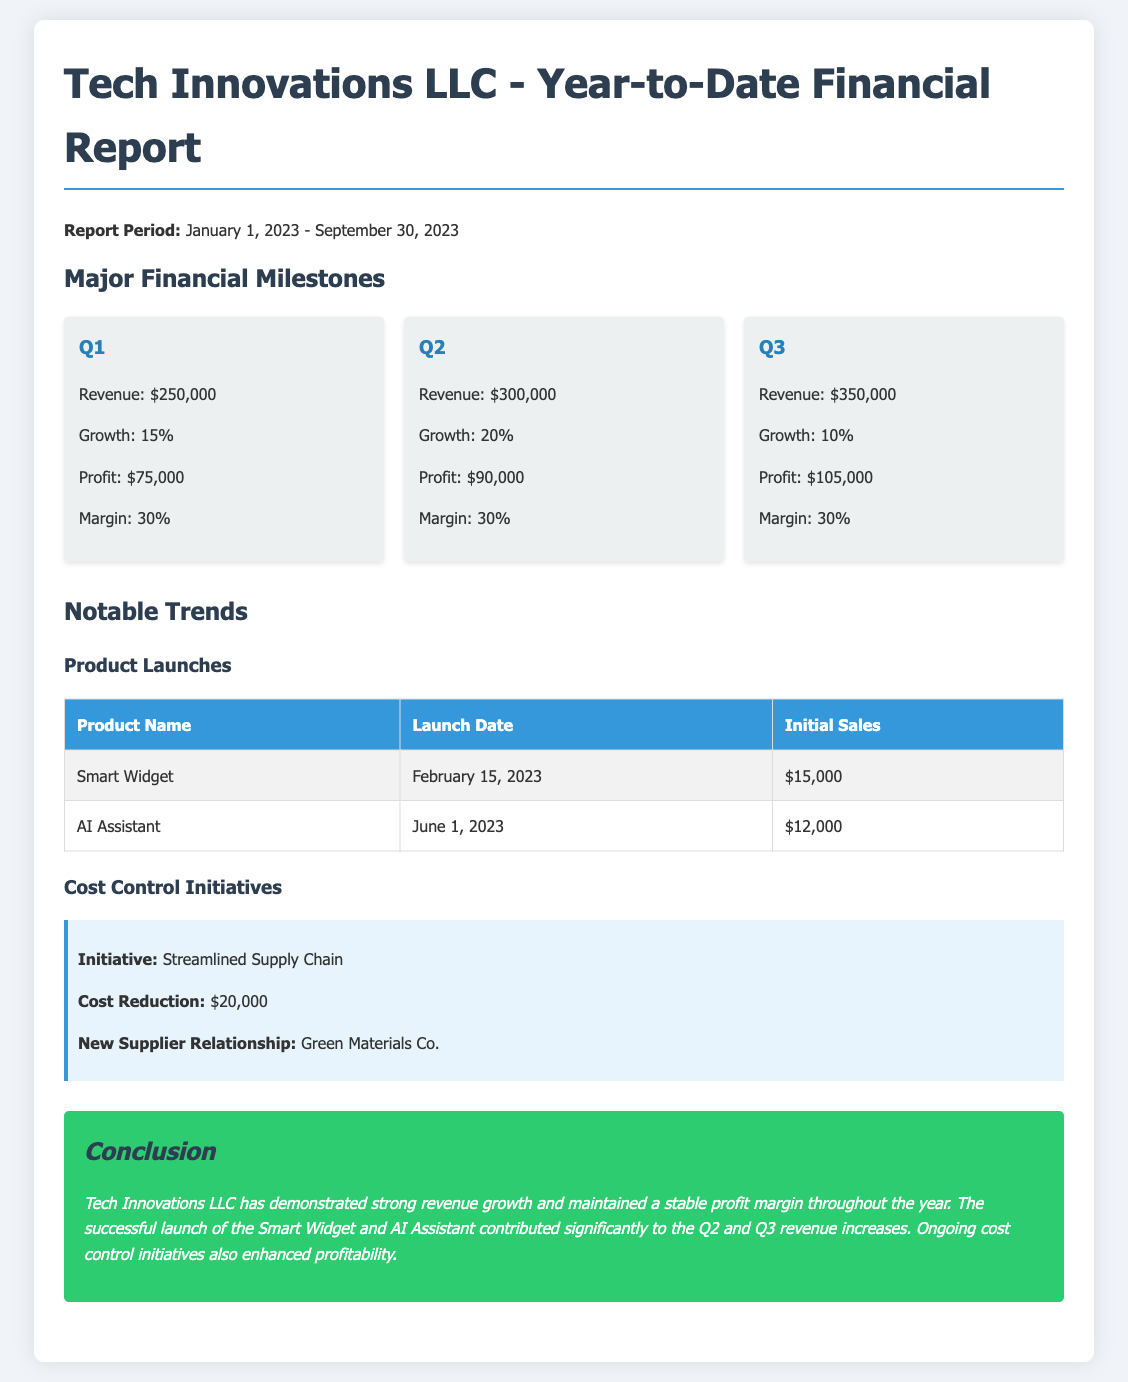What was the revenue for Q2? The revenue for Q2 is specifically stated in the document under the Q2 section, which is $300,000.
Answer: $300,000 What is the profit margin for Q3? The profit margin for Q3 is presented in the Q3 section, which is 30%.
Answer: 30% What is the total cost reduction from the cost control initiative? The total cost reduction mentioned for the cost control initiative in the document is $20,000.
Answer: $20,000 When was the Smart Widget launched? The launch date for the Smart Widget is listed in the product launches table, which is February 15, 2023.
Answer: February 15, 2023 What contributed significantly to the Q2 revenue increases? The document states that the successful launch of the Smart Widget and AI Assistant contributed to the Q2 revenue increases.
Answer: Smart Widget and AI Assistant What was the revenue growth percentage for Q1? The revenue growth percentage for Q1 is stated in the Q1 section, which is 15%.
Answer: 15% How many products were launched by September 30, 2023? The document lists two products launched by the date specified, as shown in the product launches table.
Answer: Two What financial trend is highlighted in the conclusion? The conclusion highlights strong revenue growth and stable profit margins as a key financial trend.
Answer: Strong revenue growth and stable profit margins 